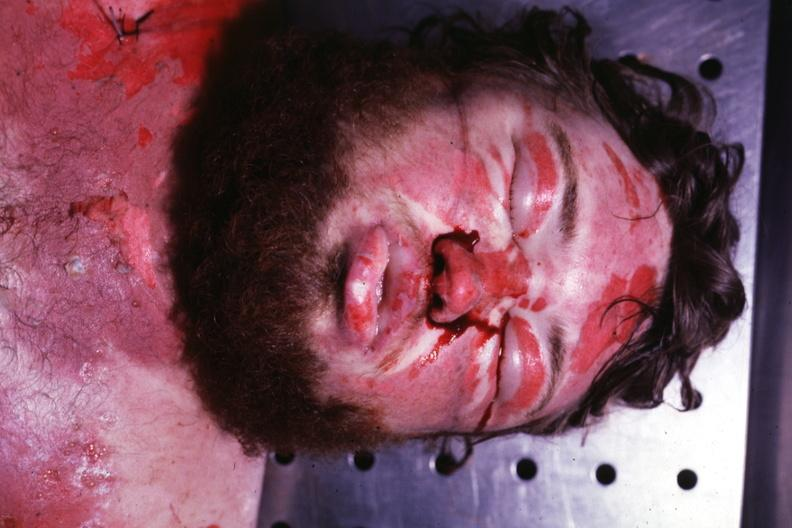what is present?
Answer the question using a single word or phrase. Edema 